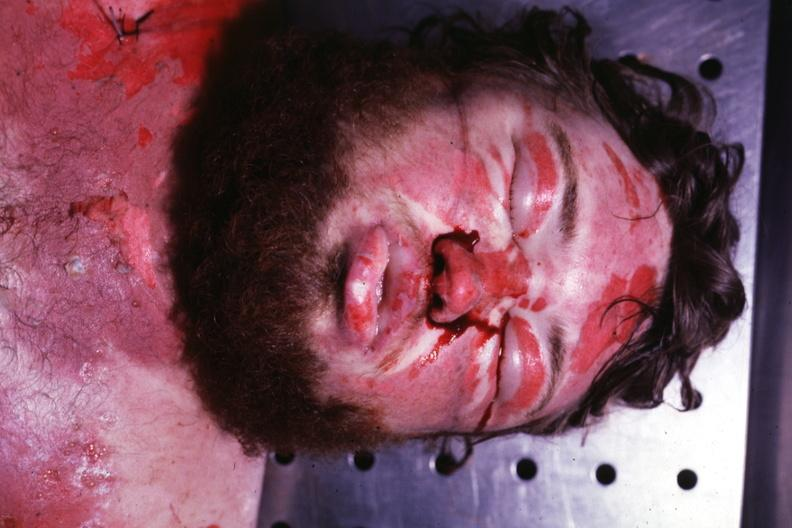what is present?
Answer the question using a single word or phrase. Edema 